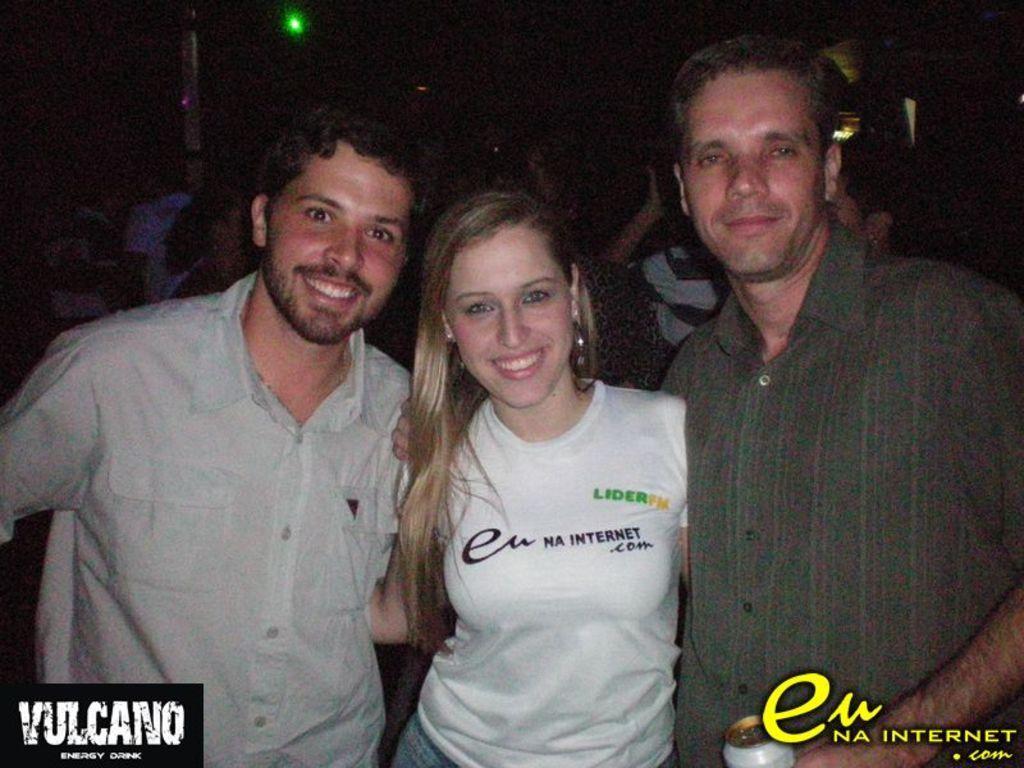Can you describe this image briefly? In this picture I can see there are three people standing and the person at the right side is smiling, the woman and a man at left are laughing. In the backdrop, there are a few more people and there are few lights attached to the ceiling. There is a logo at the bottom right and left of the image. 